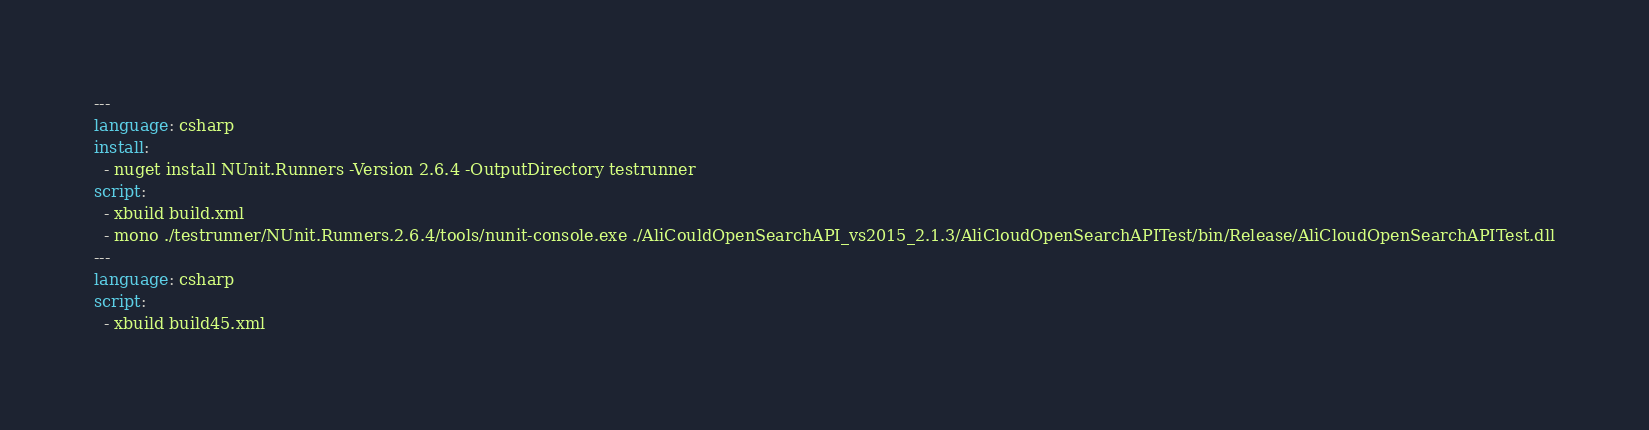Convert code to text. <code><loc_0><loc_0><loc_500><loc_500><_YAML_>---
language: csharp
install:
  - nuget install NUnit.Runners -Version 2.6.4 -OutputDirectory testrunner
script:
  - xbuild build.xml
  - mono ./testrunner/NUnit.Runners.2.6.4/tools/nunit-console.exe ./AliCouldOpenSearchAPI_vs2015_2.1.3/AliCloudOpenSearchAPITest/bin/Release/AliCloudOpenSearchAPITest.dll
---
language: csharp
script:
  - xbuild build45.xml</code> 